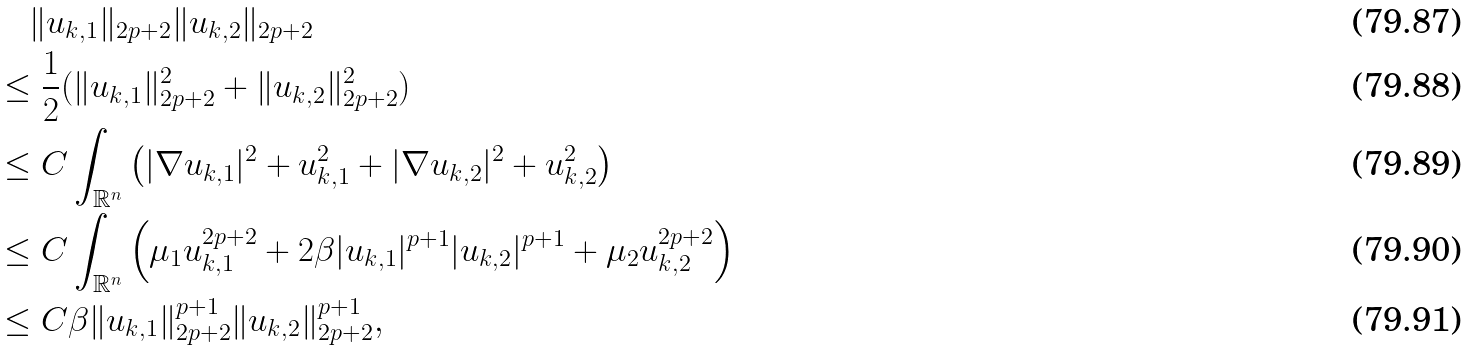<formula> <loc_0><loc_0><loc_500><loc_500>& \quad \| u _ { k , 1 } \| _ { 2 p + 2 } \| u _ { k , 2 } \| _ { 2 p + 2 } \\ & \leq \frac { 1 } { 2 } ( \| u _ { k , 1 } \| ^ { 2 } _ { 2 p + 2 } + \| u _ { k , 2 } \| ^ { 2 } _ { 2 p + 2 } ) \\ & \leq C \int _ { \mathbb { R } ^ { n } } \left ( | \nabla u _ { k , 1 } | ^ { 2 } + u _ { k , 1 } ^ { 2 } + | \nabla u _ { k , 2 } | ^ { 2 } + u _ { k , 2 } ^ { 2 } \right ) \\ & \leq C \int _ { \mathbb { R } ^ { n } } \left ( \mu _ { 1 } u _ { k , 1 } ^ { 2 p + 2 } + 2 \beta | u _ { k , 1 } | ^ { p + 1 } | u _ { k , 2 } | ^ { p + 1 } + \mu _ { 2 } u _ { k , 2 } ^ { 2 p + 2 } \right ) \\ & \leq C \beta \| u _ { k , 1 } \| ^ { p + 1 } _ { 2 p + 2 } \| u _ { k , 2 } \| _ { 2 p + 2 } ^ { p + 1 } ,</formula> 